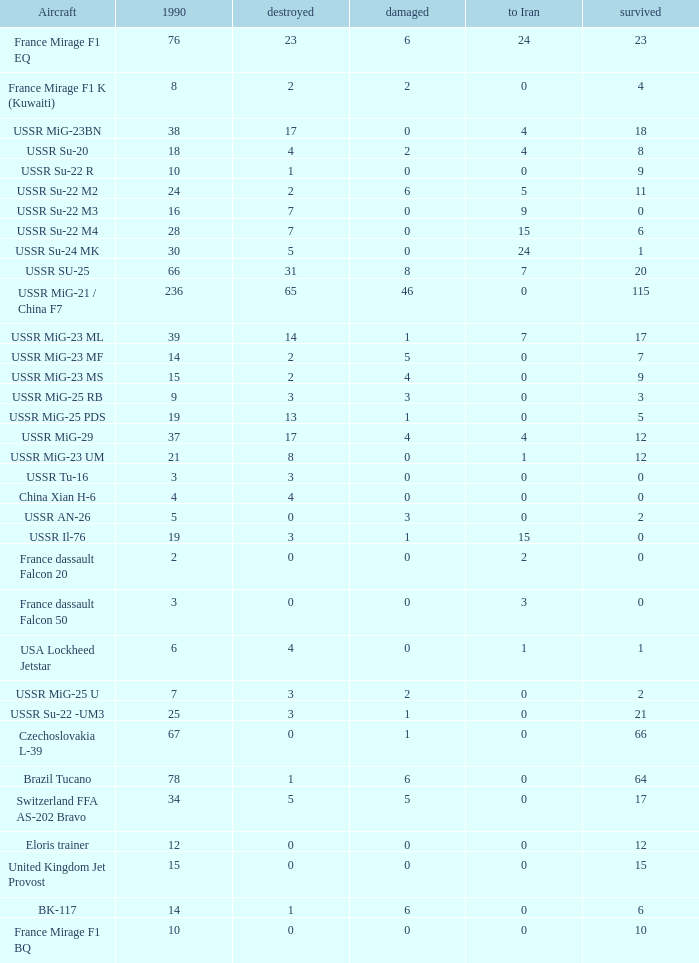0, what was the number in 1990? 1.0. 